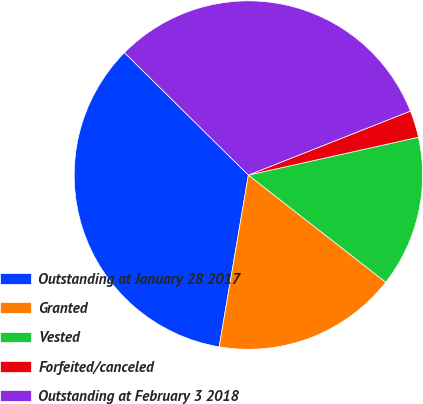Convert chart. <chart><loc_0><loc_0><loc_500><loc_500><pie_chart><fcel>Outstanding at January 28 2017<fcel>Granted<fcel>Vested<fcel>Forfeited/canceled<fcel>Outstanding at February 3 2018<nl><fcel>34.72%<fcel>17.14%<fcel>14.03%<fcel>2.5%<fcel>31.61%<nl></chart> 